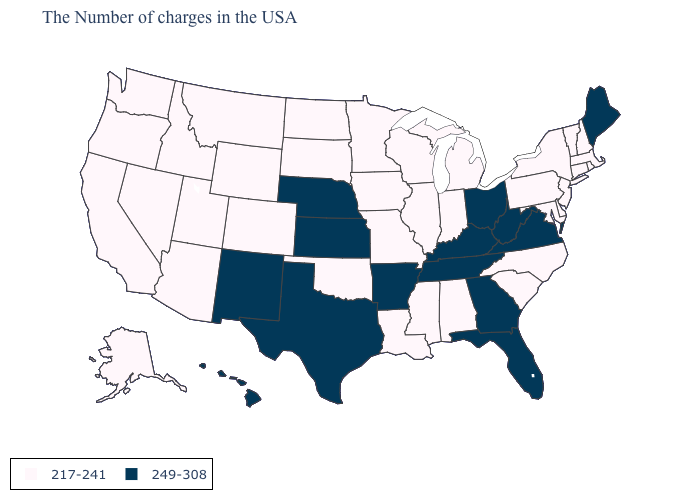Name the states that have a value in the range 249-308?
Concise answer only. Maine, Virginia, West Virginia, Ohio, Florida, Georgia, Kentucky, Tennessee, Arkansas, Kansas, Nebraska, Texas, New Mexico, Hawaii. Among the states that border Michigan , which have the lowest value?
Quick response, please. Indiana, Wisconsin. Name the states that have a value in the range 217-241?
Be succinct. Massachusetts, Rhode Island, New Hampshire, Vermont, Connecticut, New York, New Jersey, Delaware, Maryland, Pennsylvania, North Carolina, South Carolina, Michigan, Indiana, Alabama, Wisconsin, Illinois, Mississippi, Louisiana, Missouri, Minnesota, Iowa, Oklahoma, South Dakota, North Dakota, Wyoming, Colorado, Utah, Montana, Arizona, Idaho, Nevada, California, Washington, Oregon, Alaska. What is the value of Colorado?
Quick response, please. 217-241. What is the lowest value in states that border Florida?
Concise answer only. 217-241. How many symbols are there in the legend?
Keep it brief. 2. What is the value of Massachusetts?
Keep it brief. 217-241. Which states have the lowest value in the USA?
Short answer required. Massachusetts, Rhode Island, New Hampshire, Vermont, Connecticut, New York, New Jersey, Delaware, Maryland, Pennsylvania, North Carolina, South Carolina, Michigan, Indiana, Alabama, Wisconsin, Illinois, Mississippi, Louisiana, Missouri, Minnesota, Iowa, Oklahoma, South Dakota, North Dakota, Wyoming, Colorado, Utah, Montana, Arizona, Idaho, Nevada, California, Washington, Oregon, Alaska. What is the value of Illinois?
Answer briefly. 217-241. What is the highest value in the USA?
Write a very short answer. 249-308. Among the states that border Georgia , which have the highest value?
Keep it brief. Florida, Tennessee. Among the states that border Alabama , does Georgia have the highest value?
Give a very brief answer. Yes. Name the states that have a value in the range 249-308?
Short answer required. Maine, Virginia, West Virginia, Ohio, Florida, Georgia, Kentucky, Tennessee, Arkansas, Kansas, Nebraska, Texas, New Mexico, Hawaii. Does the first symbol in the legend represent the smallest category?
Answer briefly. Yes. Does Montana have the lowest value in the USA?
Keep it brief. Yes. 